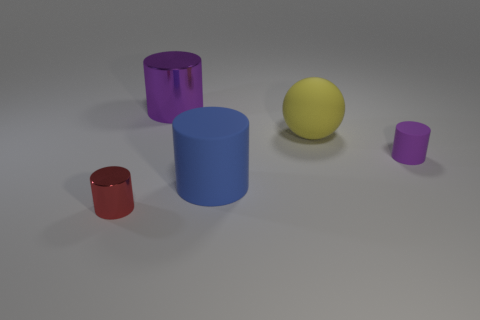Add 1 purple rubber cylinders. How many objects exist? 6 Subtract all balls. How many objects are left? 4 Subtract all large yellow cylinders. Subtract all blue rubber cylinders. How many objects are left? 4 Add 4 rubber cylinders. How many rubber cylinders are left? 6 Add 1 small rubber objects. How many small rubber objects exist? 2 Subtract 2 purple cylinders. How many objects are left? 3 